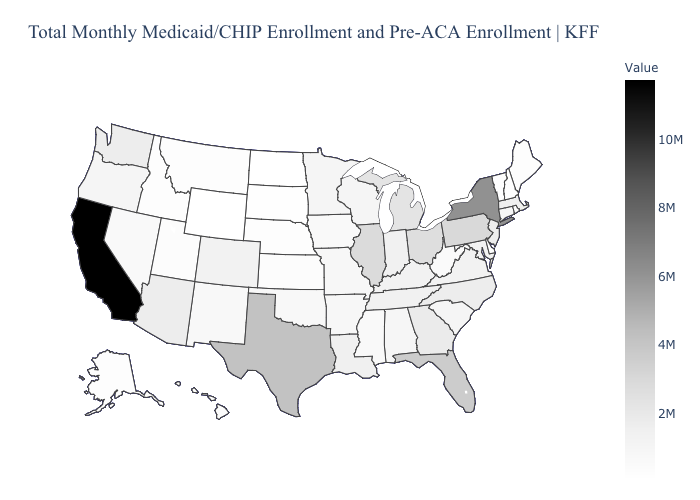Does North Carolina have the lowest value in the USA?
Give a very brief answer. No. Does California have the highest value in the USA?
Answer briefly. Yes. Which states have the lowest value in the USA?
Be succinct. Wyoming. Does Wyoming have the lowest value in the USA?
Quick response, please. Yes. Does New York have the highest value in the Northeast?
Concise answer only. Yes. Which states have the lowest value in the MidWest?
Short answer required. North Dakota. 